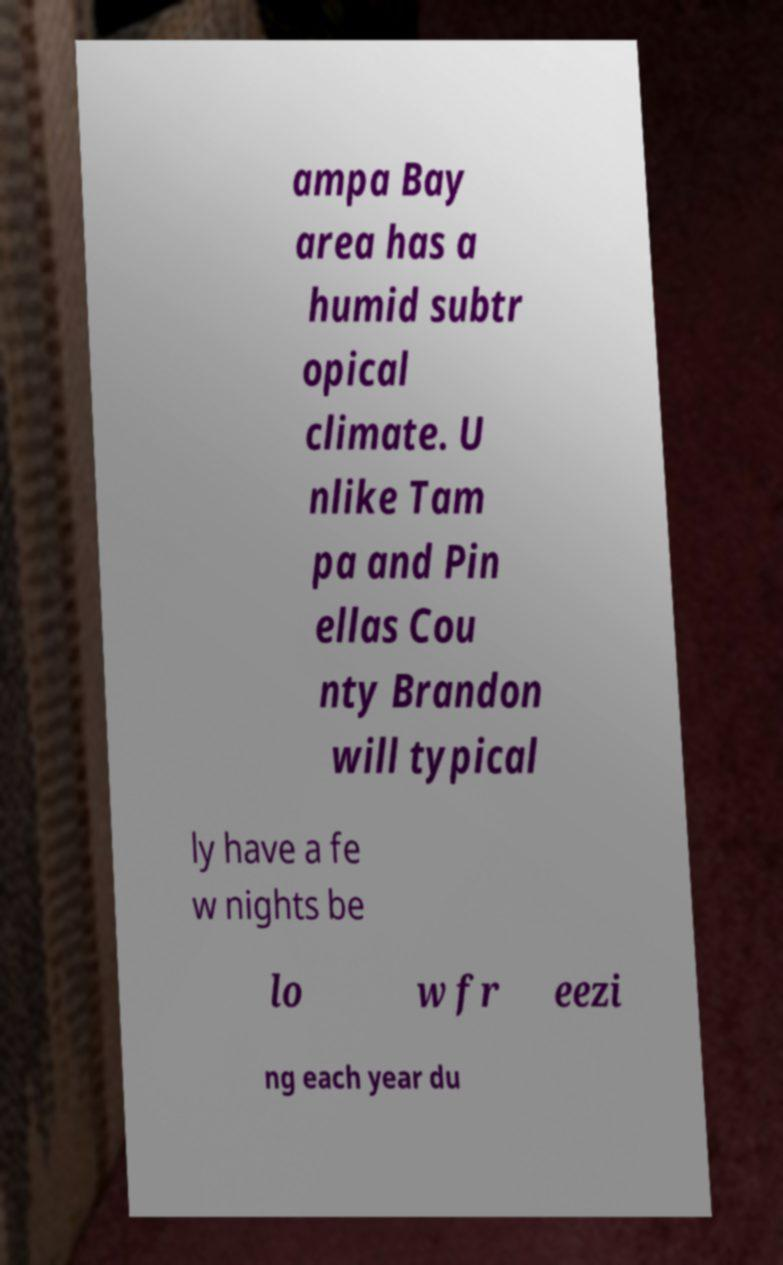There's text embedded in this image that I need extracted. Can you transcribe it verbatim? ampa Bay area has a humid subtr opical climate. U nlike Tam pa and Pin ellas Cou nty Brandon will typical ly have a fe w nights be lo w fr eezi ng each year du 